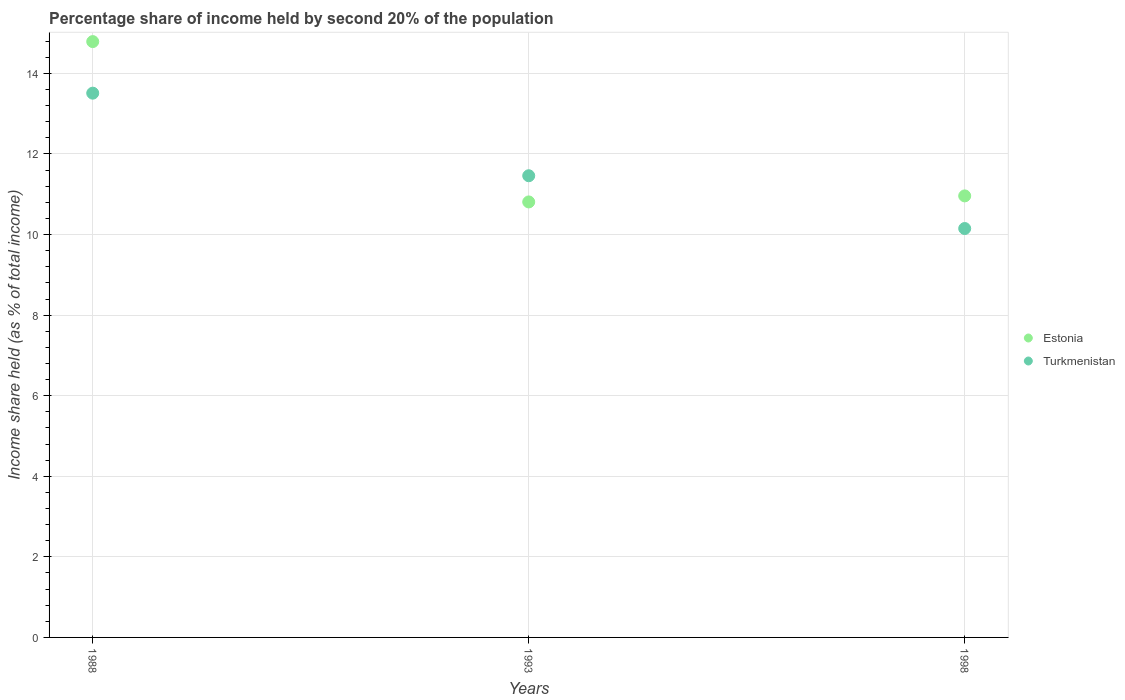Is the number of dotlines equal to the number of legend labels?
Provide a succinct answer. Yes. What is the share of income held by second 20% of the population in Turkmenistan in 1988?
Provide a short and direct response. 13.51. Across all years, what is the maximum share of income held by second 20% of the population in Estonia?
Make the answer very short. 14.79. Across all years, what is the minimum share of income held by second 20% of the population in Estonia?
Keep it short and to the point. 10.81. What is the total share of income held by second 20% of the population in Estonia in the graph?
Offer a very short reply. 36.56. What is the difference between the share of income held by second 20% of the population in Estonia in 1988 and that in 1998?
Your answer should be compact. 3.83. What is the difference between the share of income held by second 20% of the population in Estonia in 1993 and the share of income held by second 20% of the population in Turkmenistan in 1998?
Ensure brevity in your answer.  0.66. What is the average share of income held by second 20% of the population in Turkmenistan per year?
Your answer should be compact. 11.71. In the year 1993, what is the difference between the share of income held by second 20% of the population in Turkmenistan and share of income held by second 20% of the population in Estonia?
Your answer should be very brief. 0.65. In how many years, is the share of income held by second 20% of the population in Turkmenistan greater than 6.4 %?
Provide a succinct answer. 3. What is the ratio of the share of income held by second 20% of the population in Estonia in 1988 to that in 1993?
Provide a succinct answer. 1.37. What is the difference between the highest and the second highest share of income held by second 20% of the population in Turkmenistan?
Provide a succinct answer. 2.05. What is the difference between the highest and the lowest share of income held by second 20% of the population in Turkmenistan?
Your answer should be compact. 3.36. In how many years, is the share of income held by second 20% of the population in Estonia greater than the average share of income held by second 20% of the population in Estonia taken over all years?
Keep it short and to the point. 1. Is the sum of the share of income held by second 20% of the population in Turkmenistan in 1988 and 1993 greater than the maximum share of income held by second 20% of the population in Estonia across all years?
Give a very brief answer. Yes. Does the share of income held by second 20% of the population in Turkmenistan monotonically increase over the years?
Your answer should be compact. No. Is the share of income held by second 20% of the population in Estonia strictly greater than the share of income held by second 20% of the population in Turkmenistan over the years?
Your answer should be very brief. No. How many dotlines are there?
Offer a very short reply. 2. How many years are there in the graph?
Make the answer very short. 3. Does the graph contain any zero values?
Ensure brevity in your answer.  No. Does the graph contain grids?
Ensure brevity in your answer.  Yes. Where does the legend appear in the graph?
Ensure brevity in your answer.  Center right. How many legend labels are there?
Provide a short and direct response. 2. How are the legend labels stacked?
Provide a succinct answer. Vertical. What is the title of the graph?
Provide a short and direct response. Percentage share of income held by second 20% of the population. What is the label or title of the Y-axis?
Give a very brief answer. Income share held (as % of total income). What is the Income share held (as % of total income) of Estonia in 1988?
Your response must be concise. 14.79. What is the Income share held (as % of total income) of Turkmenistan in 1988?
Provide a succinct answer. 13.51. What is the Income share held (as % of total income) of Estonia in 1993?
Provide a succinct answer. 10.81. What is the Income share held (as % of total income) in Turkmenistan in 1993?
Your answer should be very brief. 11.46. What is the Income share held (as % of total income) in Estonia in 1998?
Your response must be concise. 10.96. What is the Income share held (as % of total income) of Turkmenistan in 1998?
Offer a terse response. 10.15. Across all years, what is the maximum Income share held (as % of total income) in Estonia?
Your answer should be very brief. 14.79. Across all years, what is the maximum Income share held (as % of total income) of Turkmenistan?
Ensure brevity in your answer.  13.51. Across all years, what is the minimum Income share held (as % of total income) in Estonia?
Offer a very short reply. 10.81. Across all years, what is the minimum Income share held (as % of total income) of Turkmenistan?
Give a very brief answer. 10.15. What is the total Income share held (as % of total income) of Estonia in the graph?
Provide a short and direct response. 36.56. What is the total Income share held (as % of total income) in Turkmenistan in the graph?
Offer a terse response. 35.12. What is the difference between the Income share held (as % of total income) in Estonia in 1988 and that in 1993?
Make the answer very short. 3.98. What is the difference between the Income share held (as % of total income) in Turkmenistan in 1988 and that in 1993?
Offer a terse response. 2.05. What is the difference between the Income share held (as % of total income) of Estonia in 1988 and that in 1998?
Provide a short and direct response. 3.83. What is the difference between the Income share held (as % of total income) in Turkmenistan in 1988 and that in 1998?
Offer a very short reply. 3.36. What is the difference between the Income share held (as % of total income) of Turkmenistan in 1993 and that in 1998?
Your answer should be compact. 1.31. What is the difference between the Income share held (as % of total income) in Estonia in 1988 and the Income share held (as % of total income) in Turkmenistan in 1993?
Provide a succinct answer. 3.33. What is the difference between the Income share held (as % of total income) of Estonia in 1988 and the Income share held (as % of total income) of Turkmenistan in 1998?
Your response must be concise. 4.64. What is the difference between the Income share held (as % of total income) of Estonia in 1993 and the Income share held (as % of total income) of Turkmenistan in 1998?
Your answer should be compact. 0.66. What is the average Income share held (as % of total income) of Estonia per year?
Keep it short and to the point. 12.19. What is the average Income share held (as % of total income) in Turkmenistan per year?
Provide a short and direct response. 11.71. In the year 1988, what is the difference between the Income share held (as % of total income) of Estonia and Income share held (as % of total income) of Turkmenistan?
Offer a terse response. 1.28. In the year 1993, what is the difference between the Income share held (as % of total income) of Estonia and Income share held (as % of total income) of Turkmenistan?
Keep it short and to the point. -0.65. In the year 1998, what is the difference between the Income share held (as % of total income) in Estonia and Income share held (as % of total income) in Turkmenistan?
Offer a very short reply. 0.81. What is the ratio of the Income share held (as % of total income) of Estonia in 1988 to that in 1993?
Provide a short and direct response. 1.37. What is the ratio of the Income share held (as % of total income) in Turkmenistan in 1988 to that in 1993?
Keep it short and to the point. 1.18. What is the ratio of the Income share held (as % of total income) in Estonia in 1988 to that in 1998?
Your answer should be very brief. 1.35. What is the ratio of the Income share held (as % of total income) in Turkmenistan in 1988 to that in 1998?
Offer a very short reply. 1.33. What is the ratio of the Income share held (as % of total income) in Estonia in 1993 to that in 1998?
Your response must be concise. 0.99. What is the ratio of the Income share held (as % of total income) in Turkmenistan in 1993 to that in 1998?
Keep it short and to the point. 1.13. What is the difference between the highest and the second highest Income share held (as % of total income) of Estonia?
Offer a terse response. 3.83. What is the difference between the highest and the second highest Income share held (as % of total income) of Turkmenistan?
Make the answer very short. 2.05. What is the difference between the highest and the lowest Income share held (as % of total income) in Estonia?
Provide a short and direct response. 3.98. What is the difference between the highest and the lowest Income share held (as % of total income) in Turkmenistan?
Your answer should be very brief. 3.36. 